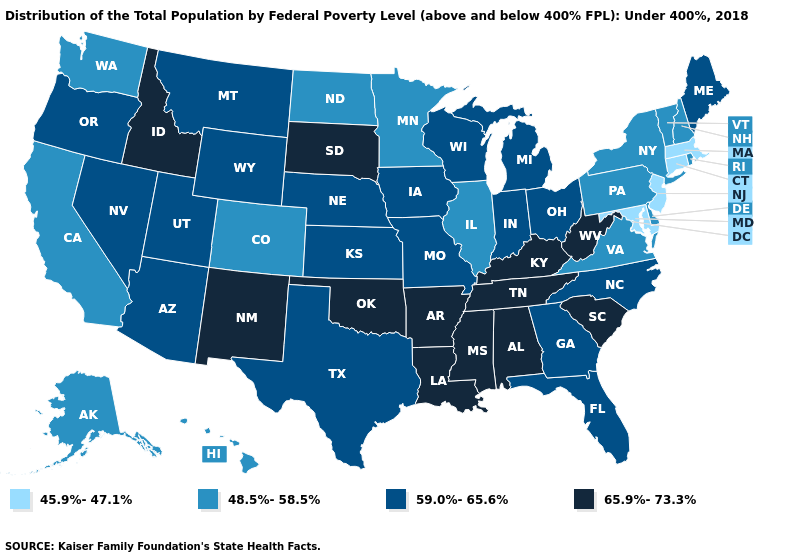Does New Mexico have the highest value in the USA?
Answer briefly. Yes. What is the value of Maine?
Be succinct. 59.0%-65.6%. What is the lowest value in states that border Georgia?
Concise answer only. 59.0%-65.6%. Name the states that have a value in the range 48.5%-58.5%?
Keep it brief. Alaska, California, Colorado, Delaware, Hawaii, Illinois, Minnesota, New Hampshire, New York, North Dakota, Pennsylvania, Rhode Island, Vermont, Virginia, Washington. Name the states that have a value in the range 45.9%-47.1%?
Quick response, please. Connecticut, Maryland, Massachusetts, New Jersey. Among the states that border Connecticut , does Rhode Island have the lowest value?
Write a very short answer. No. Among the states that border Louisiana , which have the highest value?
Quick response, please. Arkansas, Mississippi. Does Wyoming have the highest value in the USA?
Keep it brief. No. Name the states that have a value in the range 45.9%-47.1%?
Give a very brief answer. Connecticut, Maryland, Massachusetts, New Jersey. What is the highest value in states that border Alabama?
Write a very short answer. 65.9%-73.3%. What is the highest value in states that border Maryland?
Short answer required. 65.9%-73.3%. Does the map have missing data?
Give a very brief answer. No. What is the value of Nebraska?
Concise answer only. 59.0%-65.6%. What is the lowest value in the South?
Keep it brief. 45.9%-47.1%. Which states have the lowest value in the USA?
Keep it brief. Connecticut, Maryland, Massachusetts, New Jersey. 